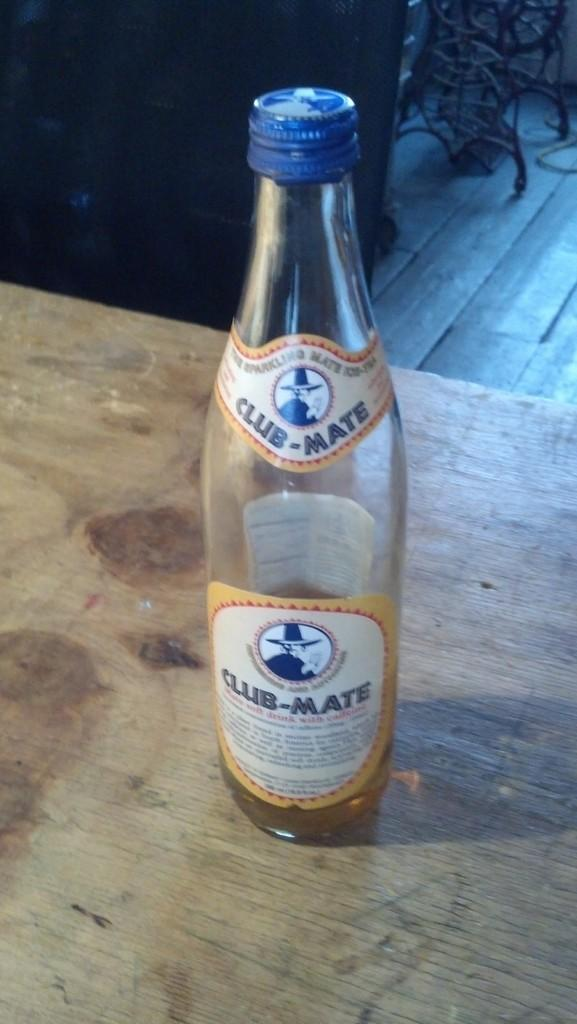<image>
Relay a brief, clear account of the picture shown. An almost empty bottle of Club-Mate sits on a stained wooden table. 